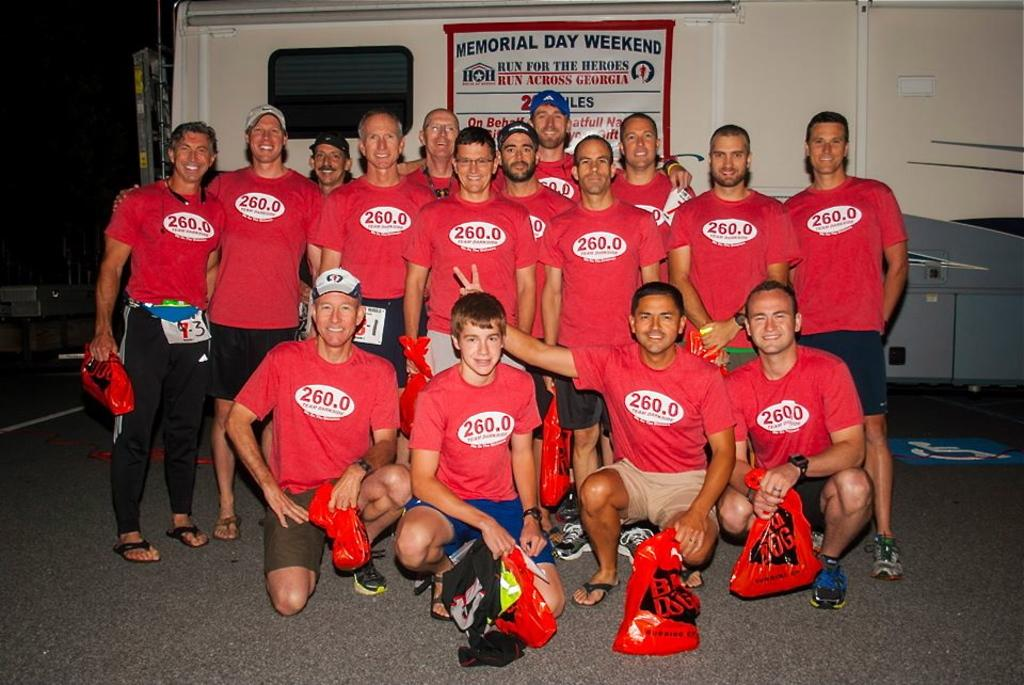<image>
Share a concise interpretation of the image provided. The group of men pictured are all wearing matchin red tops with 260.0 written on them. 